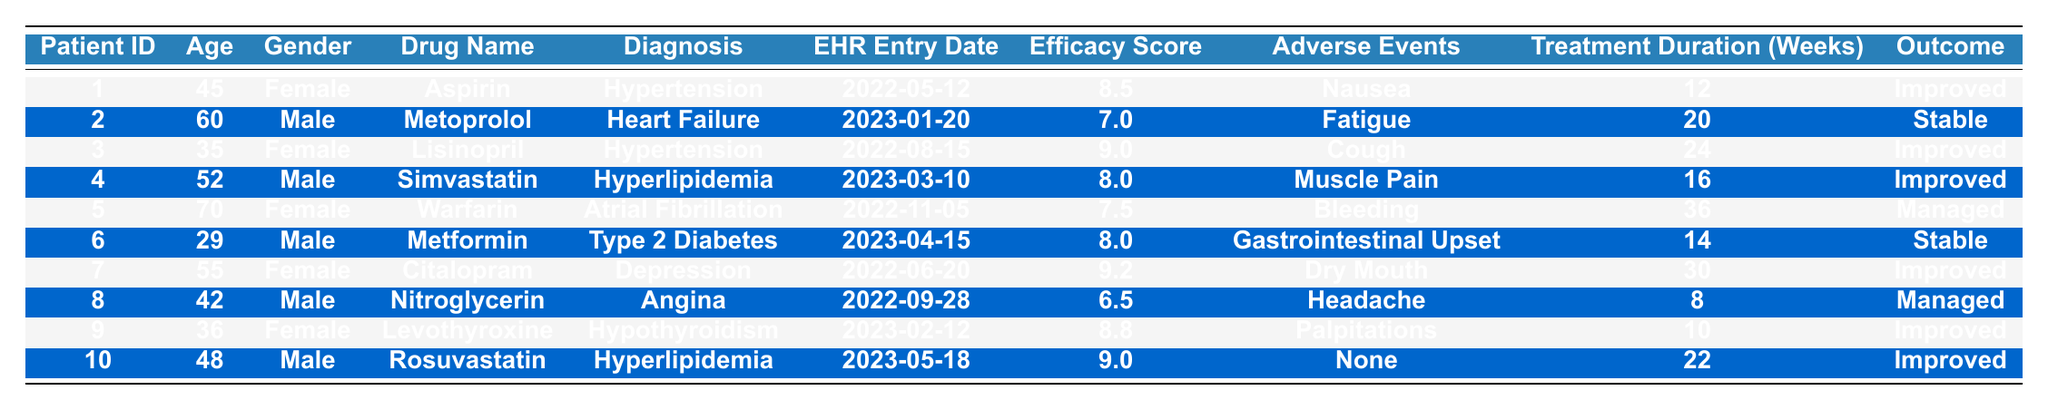What is the efficacy score for the drug "Warfarin"? The table shows that "Warfarin" has an efficacy score of 7.5 listed under Patient ID 5.
Answer: 7.5 How many weeks was the treatment duration for "Citalopram"? According to the table, the treatment duration for "Citalopram" is 30 weeks under Patient ID 7.
Answer: 30 Which drug has the highest efficacy score? Upon reviewing the efficacy scores, "Citalopram" has the highest score of 9.2 among all listed drugs.
Answer: Citalopram Was there any patient that experienced "None" as an adverse event? Reviewing the table shows that Patient ID 10 experienced "None" as an adverse event while taking "Rosuvastatin".
Answer: Yes What is the average efficacy score of all patients treated with the drug "Metoprolol"? There is only one patient treated with "Metoprolol" which is Patient ID 2 with an efficacy score of 7.0. Therefore, the average is 7.0.
Answer: 7.0 What is the treatment duration for the patient with the lowest efficacy score? The drug with the lowest efficacy score is "Nitroglycerin" at 6.5, which has a treatment duration of 8 weeks for Patient ID 8.
Answer: 8 weeks How does the average efficacy score of male patients compare to female patients? The average efficacy score for males is (7.0 + 8.0 + 9.0 + 6.5) / 4 = 7.625, and for females is (8.5 + 9.0 + 9.2 + 7.5 + 8.8) / 5 = 8.6. Thus, females have a higher average efficacy score.
Answer: Females have a higher average efficacy score What trends can you observe in the outcomes based on the efficacy scores? Patients with higher efficacy scores (above 8.0) generally show "Improved" outcomes while those with scores below 8.0 show either "Stable" or "Managed" outcomes.
Answer: Higher efficacy scores tend to show "Improved" outcomes Is there a correlation between age and efficacy score in this dataset? Analyzing the table, we can see that the efficacy scores do not have a consistent trend with age; therefore, no clear correlation can be established based on the available data.
Answer: No clear correlation Which drug had the longest treatment duration, and what was the outcome? "Warfarin" had the longest treatment duration of 36 weeks, and the outcome was "Managed" for Patient ID 5.
Answer: Warfarin, Managed 